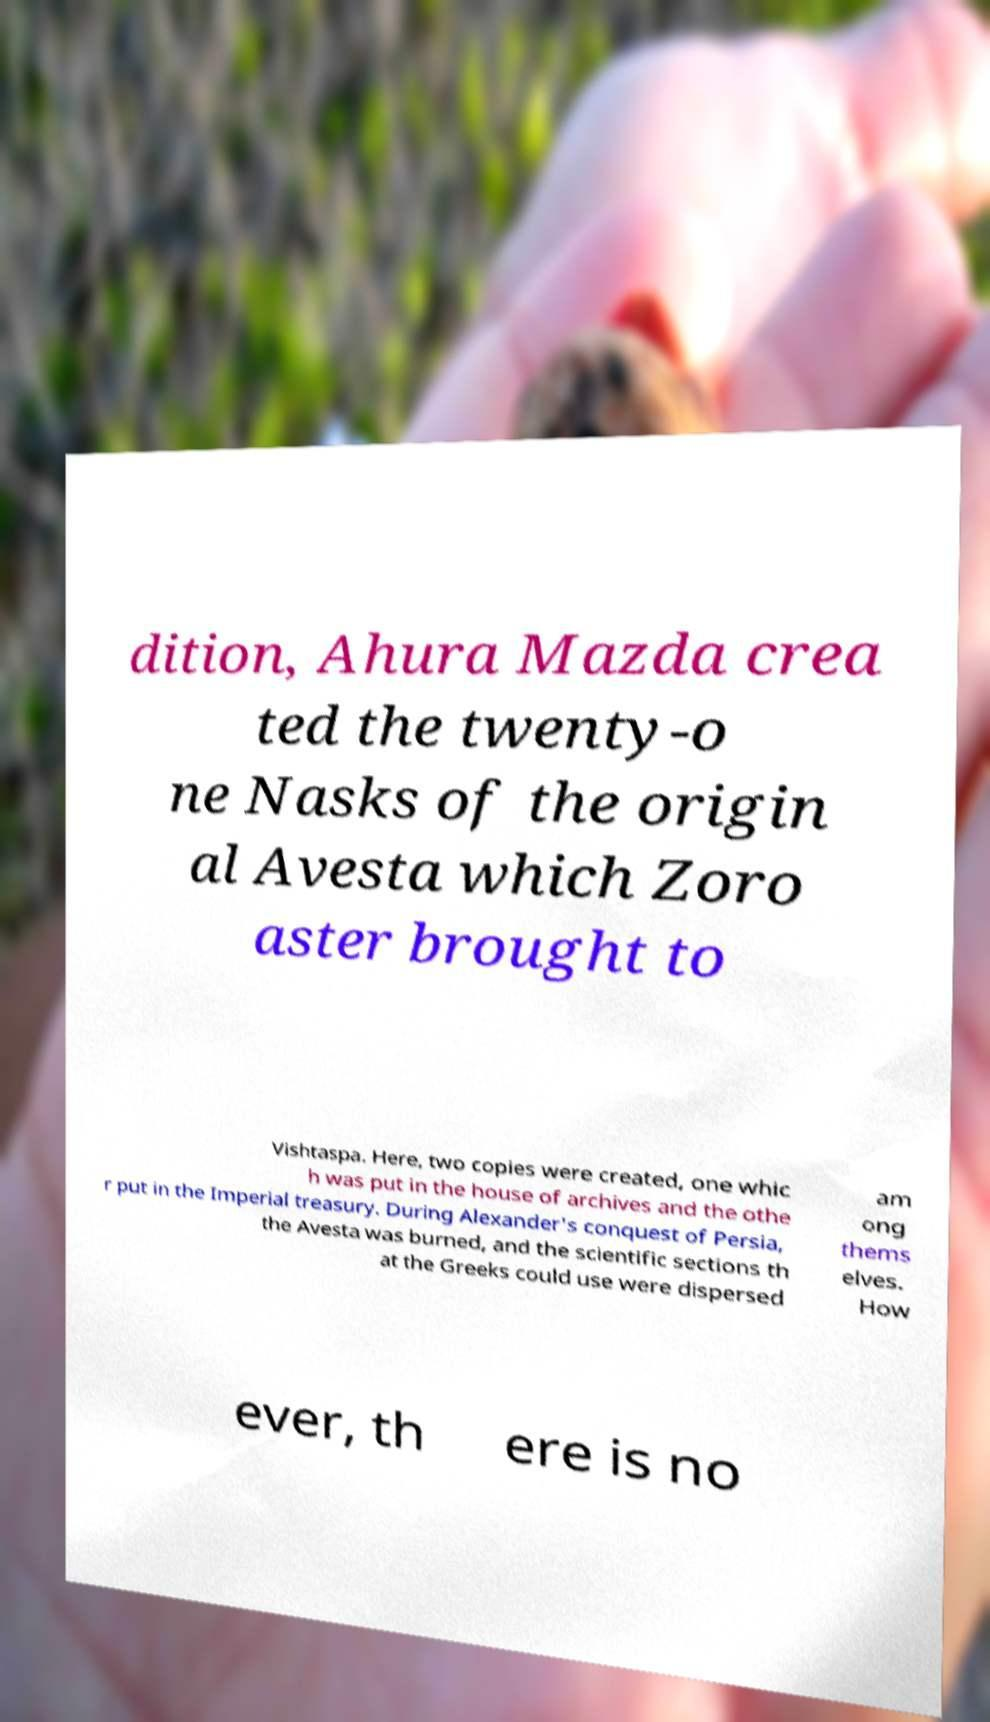For documentation purposes, I need the text within this image transcribed. Could you provide that? dition, Ahura Mazda crea ted the twenty-o ne Nasks of the origin al Avesta which Zoro aster brought to Vishtaspa. Here, two copies were created, one whic h was put in the house of archives and the othe r put in the Imperial treasury. During Alexander's conquest of Persia, the Avesta was burned, and the scientific sections th at the Greeks could use were dispersed am ong thems elves. How ever, th ere is no 